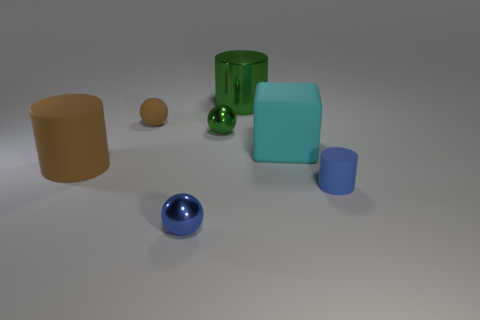Which object stands out the most in the image and why? The blue shiny sphere stands out the most due to its high reflectivity and the contrast it creates with the overall muted color palette of the scene. Its position in the foreground further draws the viewer's attention. Could the lighting in the scene be affecting how the colors of the objects appear? Absolutely, lighting plays a crucial role in the perception of color. Directional lighting and shadows in the scene can influence how we perceive the color and texture of objects. Areas in direct light may appear brighter and more saturated, while those in shadow can seem darker and less vibrant. Additionally, the surface properties of objects will interact differently with the light, affecting our color perception. 